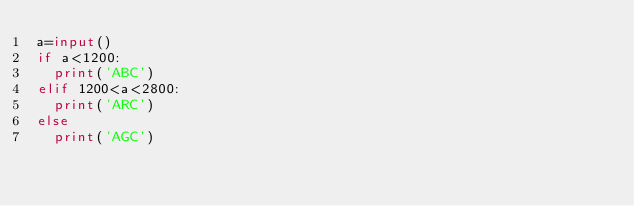Convert code to text. <code><loc_0><loc_0><loc_500><loc_500><_Python_>a=input()
if a<1200:
  print('ABC')
elif 1200<a<2800:
  print('ARC')
else
  print('AGC')</code> 